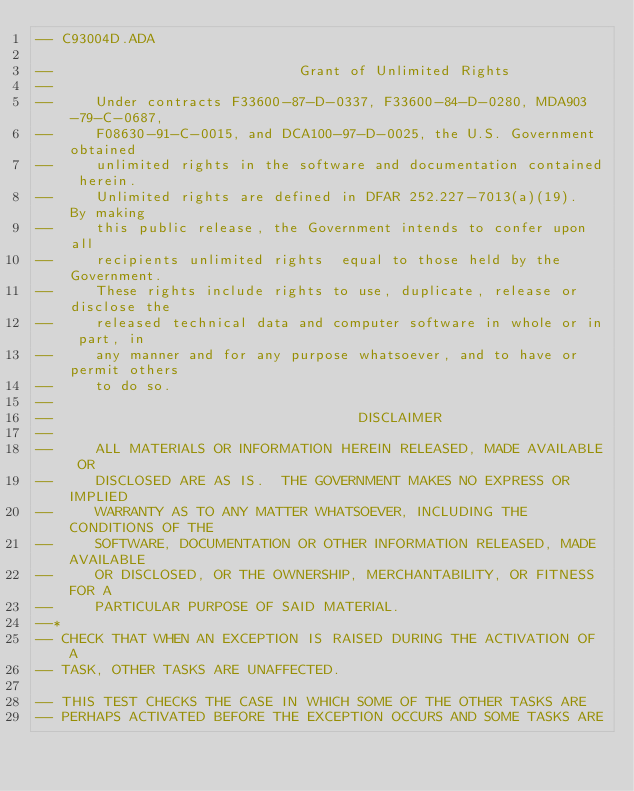<code> <loc_0><loc_0><loc_500><loc_500><_Ada_>-- C93004D.ADA

--                             Grant of Unlimited Rights
--
--     Under contracts F33600-87-D-0337, F33600-84-D-0280, MDA903-79-C-0687,
--     F08630-91-C-0015, and DCA100-97-D-0025, the U.S. Government obtained 
--     unlimited rights in the software and documentation contained herein.
--     Unlimited rights are defined in DFAR 252.227-7013(a)(19).  By making 
--     this public release, the Government intends to confer upon all 
--     recipients unlimited rights  equal to those held by the Government.  
--     These rights include rights to use, duplicate, release or disclose the 
--     released technical data and computer software in whole or in part, in 
--     any manner and for any purpose whatsoever, and to have or permit others 
--     to do so.
--
--                                    DISCLAIMER
--
--     ALL MATERIALS OR INFORMATION HEREIN RELEASED, MADE AVAILABLE OR
--     DISCLOSED ARE AS IS.  THE GOVERNMENT MAKES NO EXPRESS OR IMPLIED 
--     WARRANTY AS TO ANY MATTER WHATSOEVER, INCLUDING THE CONDITIONS OF THE
--     SOFTWARE, DOCUMENTATION OR OTHER INFORMATION RELEASED, MADE AVAILABLE 
--     OR DISCLOSED, OR THE OWNERSHIP, MERCHANTABILITY, OR FITNESS FOR A
--     PARTICULAR PURPOSE OF SAID MATERIAL.
--*
-- CHECK THAT WHEN AN EXCEPTION IS RAISED DURING THE ACTIVATION OF A
-- TASK, OTHER TASKS ARE UNAFFECTED.

-- THIS TEST CHECKS THE CASE IN WHICH SOME OF THE OTHER TASKS ARE 
-- PERHAPS ACTIVATED BEFORE THE EXCEPTION OCCURS AND SOME TASKS ARE </code> 